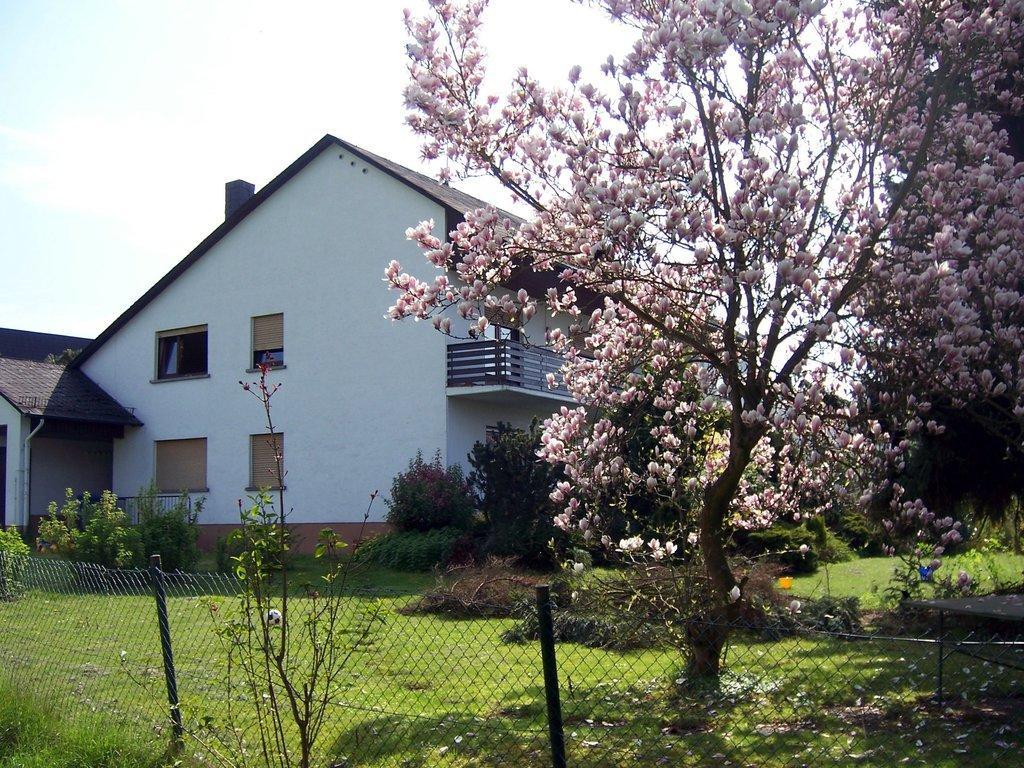In one or two sentences, can you explain what this image depicts? In this image I can see few flowers in lite pink color, background I can see few trees in green color, fencing, a building in white color and the sky is in white color. 